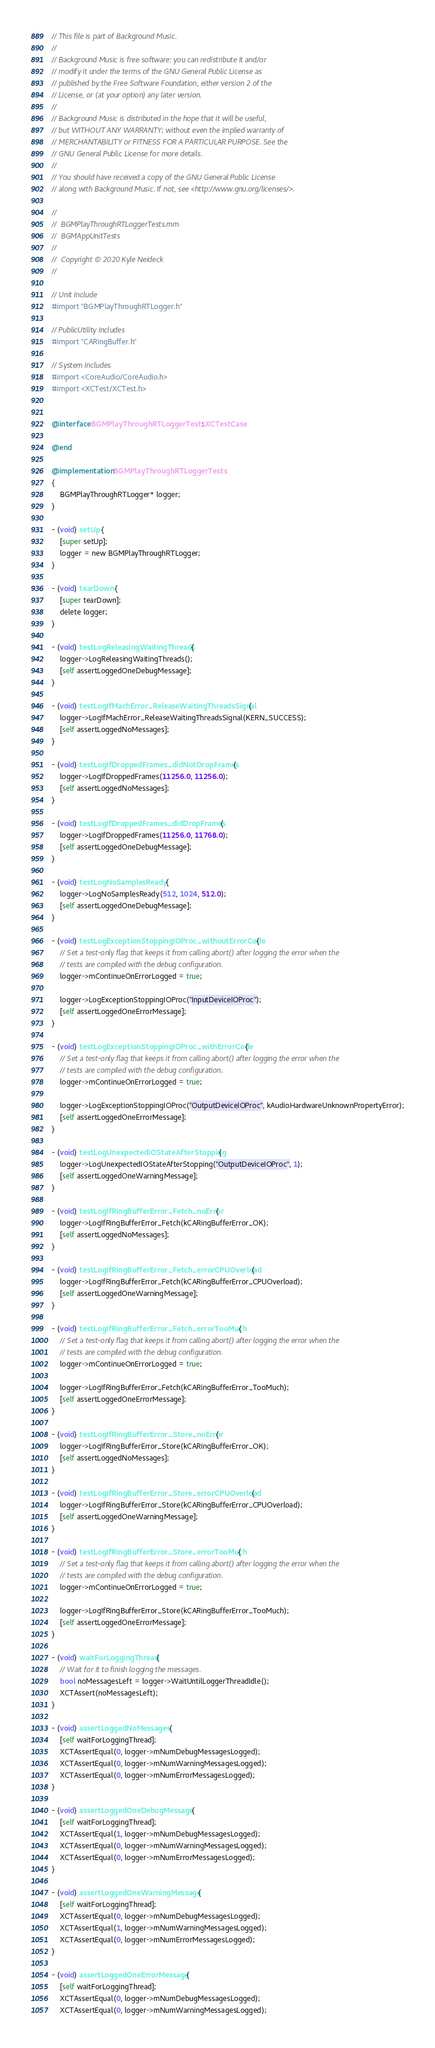Convert code to text. <code><loc_0><loc_0><loc_500><loc_500><_ObjectiveC_>// This file is part of Background Music.
//
// Background Music is free software: you can redistribute it and/or
// modify it under the terms of the GNU General Public License as
// published by the Free Software Foundation, either version 2 of the
// License, or (at your option) any later version.
//
// Background Music is distributed in the hope that it will be useful,
// but WITHOUT ANY WARRANTY; without even the implied warranty of
// MERCHANTABILITY or FITNESS FOR A PARTICULAR PURPOSE. See the
// GNU General Public License for more details.
//
// You should have received a copy of the GNU General Public License
// along with Background Music. If not, see <http://www.gnu.org/licenses/>.

//
//  BGMPlayThroughRTLoggerTests.mm
//  BGMAppUnitTests
//
//  Copyright © 2020 Kyle Neideck
//

// Unit Include
#import "BGMPlayThroughRTLogger.h"

// PublicUtility Includes
#import "CARingBuffer.h"

// System Includes
#import <CoreAudio/CoreAudio.h>
#import <XCTest/XCTest.h>


@interface BGMPlayThroughRTLoggerTests : XCTestCase

@end

@implementation BGMPlayThroughRTLoggerTests
{
    BGMPlayThroughRTLogger* logger;
}

- (void) setUp {
    [super setUp];
    logger = new BGMPlayThroughRTLogger;
}

- (void) tearDown {
    [super tearDown];
    delete logger;
}

- (void) testLogReleasingWaitingThreads {
    logger->LogReleasingWaitingThreads();
    [self assertLoggedOneDebugMessage];
}

- (void) testLogIfMachError_ReleaseWaitingThreadsSignal {
    logger->LogIfMachError_ReleaseWaitingThreadsSignal(KERN_SUCCESS);
    [self assertLoggedNoMessages];
}

- (void) testLogIfDroppedFrames_didNotDropFrames {
    logger->LogIfDroppedFrames(11256.0, 11256.0);
    [self assertLoggedNoMessages];
}

- (void) testLogIfDroppedFrames_didDropFrames {
    logger->LogIfDroppedFrames(11256.0, 11768.0);
    [self assertLoggedOneDebugMessage];
}

- (void) testLogNoSamplesReady {
    logger->LogNoSamplesReady(512, 1024, 512.0);
    [self assertLoggedOneDebugMessage];
}

- (void) testLogExceptionStoppingIOProc_withoutErrorCode {
    // Set a test-only flag that keeps it from calling abort() after logging the error when the
    // tests are compiled with the debug configuration.
    logger->mContinueOnErrorLogged = true;

    logger->LogExceptionStoppingIOProc("InputDeviceIOProc");
    [self assertLoggedOneErrorMessage];
}

- (void) testLogExceptionStoppingIOProc_withErrorCode {
    // Set a test-only flag that keeps it from calling abort() after logging the error when the
    // tests are compiled with the debug configuration.
    logger->mContinueOnErrorLogged = true;

    logger->LogExceptionStoppingIOProc("OutputDeviceIOProc", kAudioHardwareUnknownPropertyError);
    [self assertLoggedOneErrorMessage];
}

- (void) testLogUnexpectedIOStateAfterStopping {
    logger->LogUnexpectedIOStateAfterStopping("OutputDeviceIOProc", 1);
    [self assertLoggedOneWarningMessage];
}

- (void) testLogIfRingBufferError_Fetch_noError {
    logger->LogIfRingBufferError_Fetch(kCARingBufferError_OK);
    [self assertLoggedNoMessages];
}

- (void) testLogIfRingBufferError_Fetch_errorCPUOverload {
    logger->LogIfRingBufferError_Fetch(kCARingBufferError_CPUOverload);
    [self assertLoggedOneWarningMessage];
}

- (void) testLogIfRingBufferError_Fetch_errorTooMuch {
    // Set a test-only flag that keeps it from calling abort() after logging the error when the
    // tests are compiled with the debug configuration.
    logger->mContinueOnErrorLogged = true;

    logger->LogIfRingBufferError_Fetch(kCARingBufferError_TooMuch);
    [self assertLoggedOneErrorMessage];
}

- (void) testLogIfRingBufferError_Store_noError {
    logger->LogIfRingBufferError_Store(kCARingBufferError_OK);
    [self assertLoggedNoMessages];
}

- (void) testLogIfRingBufferError_Store_errorCPUOverload {
    logger->LogIfRingBufferError_Store(kCARingBufferError_CPUOverload);
    [self assertLoggedOneWarningMessage];
}

- (void) testLogIfRingBufferError_Store_errorTooMuch {
    // Set a test-only flag that keeps it from calling abort() after logging the error when the
    // tests are compiled with the debug configuration.
    logger->mContinueOnErrorLogged = true;

    logger->LogIfRingBufferError_Store(kCARingBufferError_TooMuch);
    [self assertLoggedOneErrorMessage];
}

- (void) waitForLoggingThread {
    // Wait for it to finish logging the messages.
    bool noMessagesLeft = logger->WaitUntilLoggerThreadIdle();
    XCTAssert(noMessagesLeft);
}

- (void) assertLoggedNoMessages {
    [self waitForLoggingThread];
    XCTAssertEqual(0, logger->mNumDebugMessagesLogged);
    XCTAssertEqual(0, logger->mNumWarningMessagesLogged);
    XCTAssertEqual(0, logger->mNumErrorMessagesLogged);
}

- (void) assertLoggedOneDebugMessage {
    [self waitForLoggingThread];
    XCTAssertEqual(1, logger->mNumDebugMessagesLogged);
    XCTAssertEqual(0, logger->mNumWarningMessagesLogged);
    XCTAssertEqual(0, logger->mNumErrorMessagesLogged);
}

- (void) assertLoggedOneWarningMessage {
    [self waitForLoggingThread];
    XCTAssertEqual(0, logger->mNumDebugMessagesLogged);
    XCTAssertEqual(1, logger->mNumWarningMessagesLogged);
    XCTAssertEqual(0, logger->mNumErrorMessagesLogged);
}

- (void) assertLoggedOneErrorMessage {
    [self waitForLoggingThread];
    XCTAssertEqual(0, logger->mNumDebugMessagesLogged);
    XCTAssertEqual(0, logger->mNumWarningMessagesLogged);</code> 